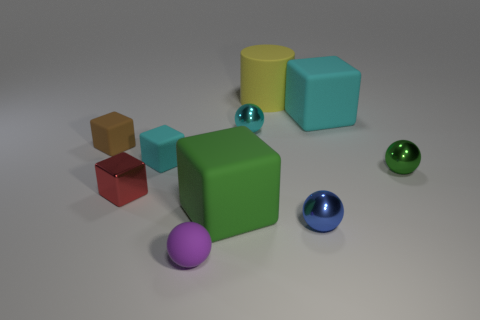Does the tiny red metal thing have the same shape as the large rubber thing that is in front of the green metal thing?
Give a very brief answer. Yes. What number of other things are the same size as the red shiny block?
Your answer should be compact. 6. What number of red things are either small cubes or shiny spheres?
Your answer should be compact. 1. How many rubber things are in front of the large matte cylinder and right of the small red thing?
Give a very brief answer. 4. The green thing that is to the left of the yellow cylinder behind the tiny metal sphere that is to the left of the cylinder is made of what material?
Provide a succinct answer. Rubber. How many tiny cubes have the same material as the yellow cylinder?
Provide a succinct answer. 2. The cyan metal thing that is the same size as the red cube is what shape?
Make the answer very short. Sphere. Are there any big rubber objects to the right of the big cyan rubber object?
Your answer should be compact. No. Are there any other rubber things that have the same shape as the big green rubber object?
Your answer should be compact. Yes. Is the shape of the cyan rubber thing left of the tiny purple matte thing the same as the tiny metal object that is behind the tiny green object?
Your answer should be compact. No. 